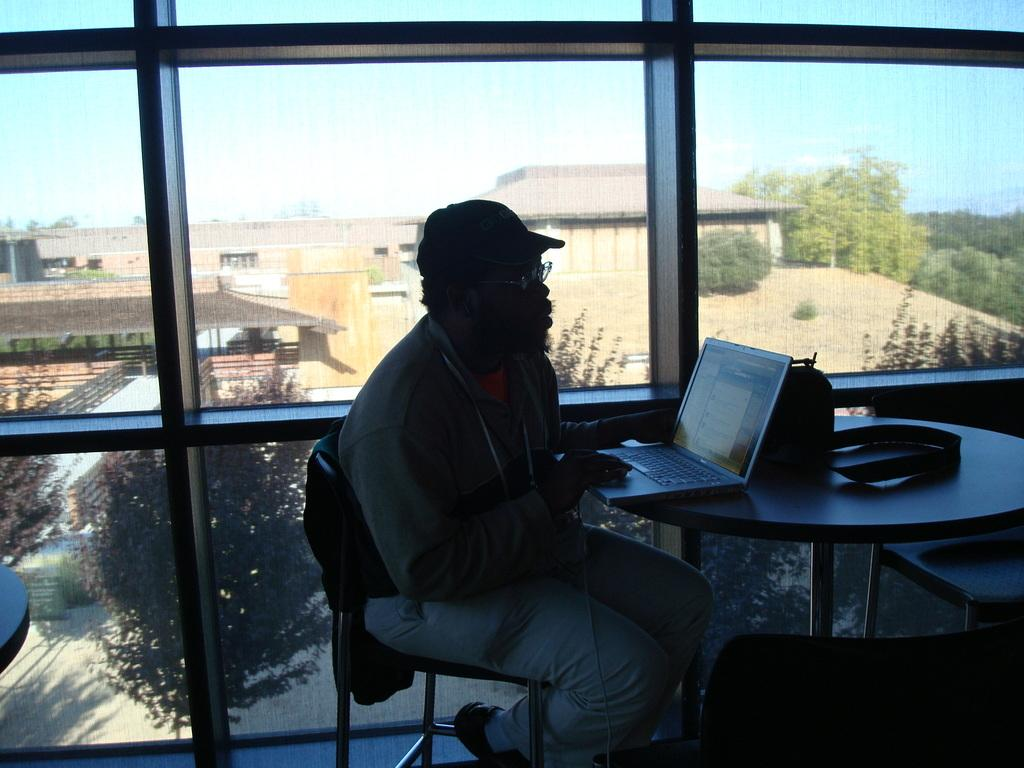What is the person in the image doing? The person is sitting on a chair and using a laptop. What furniture is present in the image? There is a table and a chair in the image. What object can be seen on the table? There is a glass object on the table. What can be seen in the background of the image? There is a tree and a building in the background of the image. What type of bone is being used by the carpenter in the image? There is no carpenter or bone present in the image. What type of structure is being built by the carpenter in the image? There is no carpenter or structure being built in the image. 